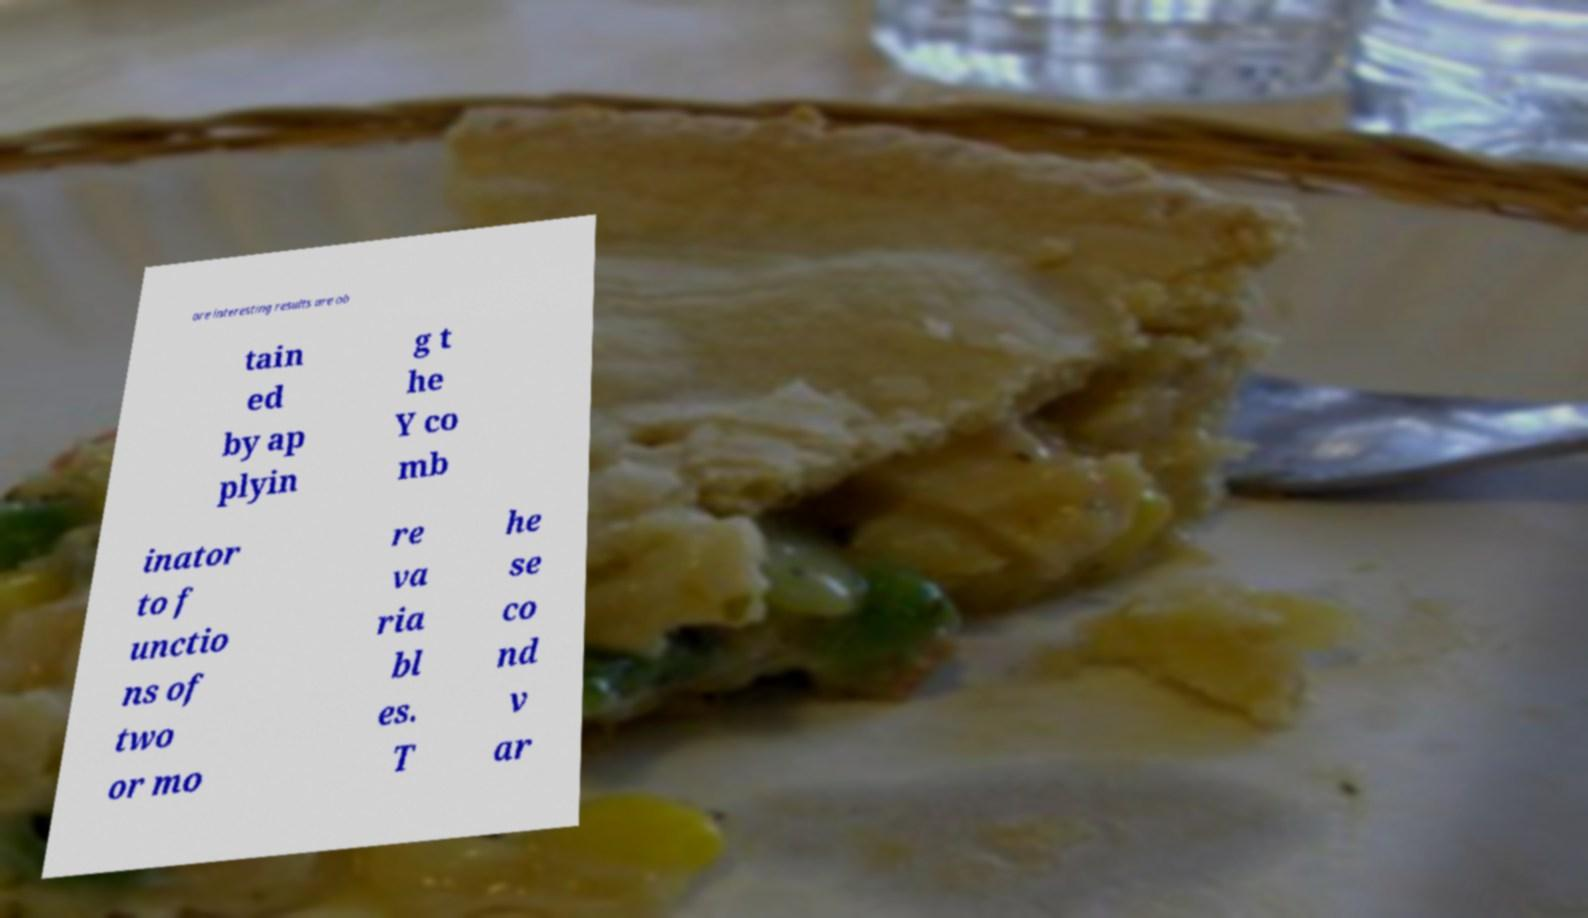I need the written content from this picture converted into text. Can you do that? ore interesting results are ob tain ed by ap plyin g t he Y co mb inator to f unctio ns of two or mo re va ria bl es. T he se co nd v ar 